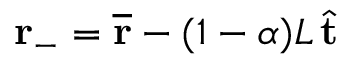<formula> <loc_0><loc_0><loc_500><loc_500>r _ { - } = \overline { r } - ( 1 - \alpha ) L \, \hat { t }</formula> 